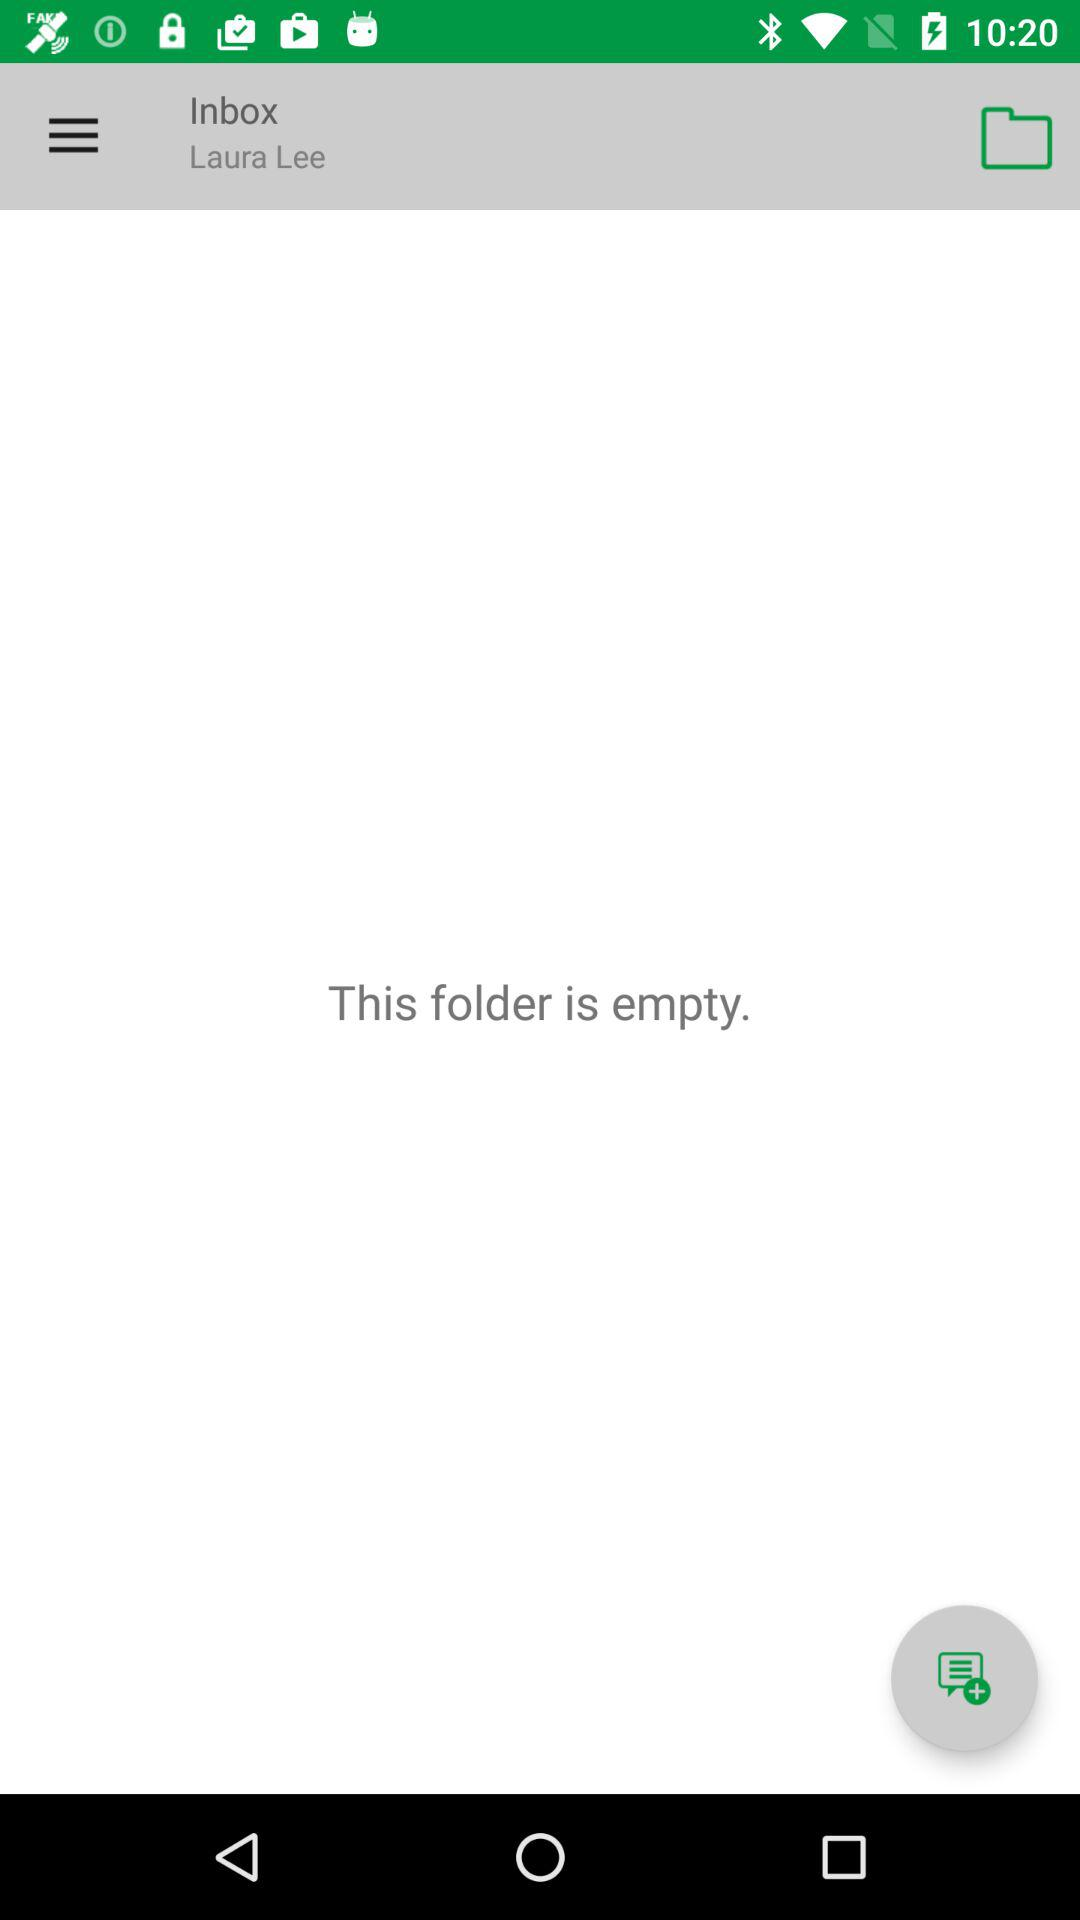When did Laura Lee last log in?
When the provided information is insufficient, respond with <no answer>. <no answer> 